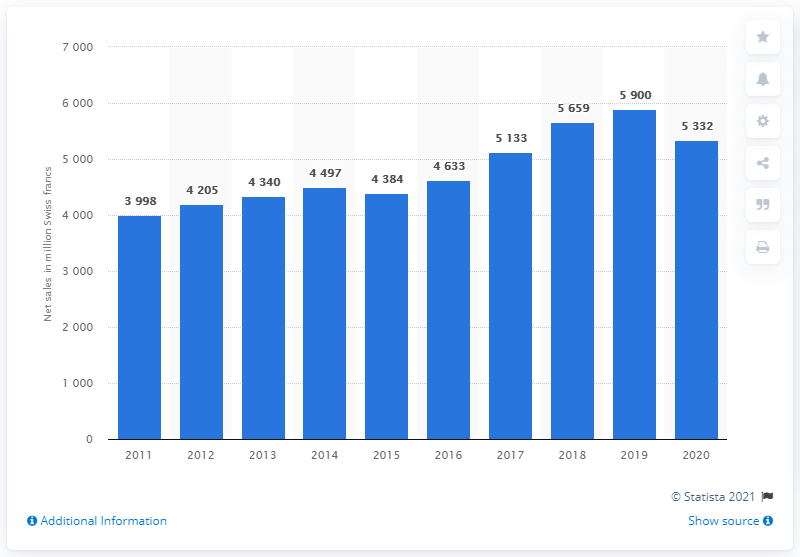Indicate a few pertinent items in this graphic. Hilti achieved net sales of CHF 5,332 million in 2020. 